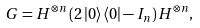<formula> <loc_0><loc_0><loc_500><loc_500>G = H ^ { \otimes n } \left ( { 2 \left | 0 \right \rangle \left \langle 0 \right | - I _ { n } } \right ) H ^ { \otimes n } ,</formula> 